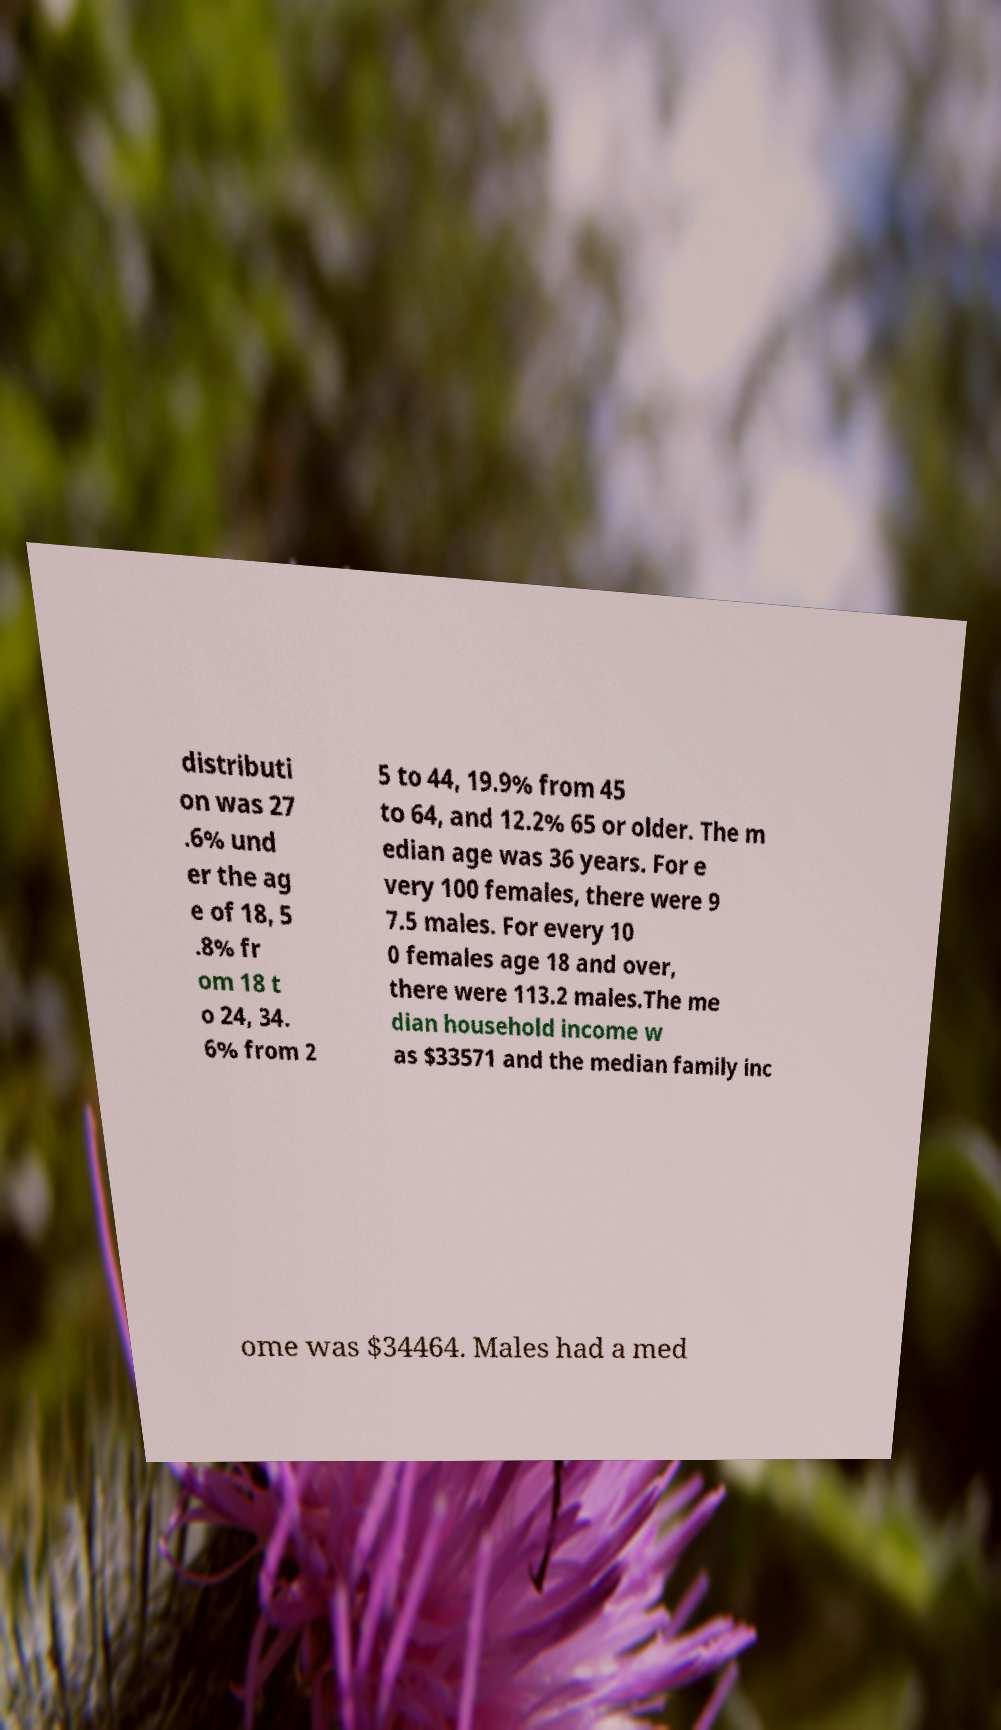Can you accurately transcribe the text from the provided image for me? distributi on was 27 .6% und er the ag e of 18, 5 .8% fr om 18 t o 24, 34. 6% from 2 5 to 44, 19.9% from 45 to 64, and 12.2% 65 or older. The m edian age was 36 years. For e very 100 females, there were 9 7.5 males. For every 10 0 females age 18 and over, there were 113.2 males.The me dian household income w as $33571 and the median family inc ome was $34464. Males had a med 